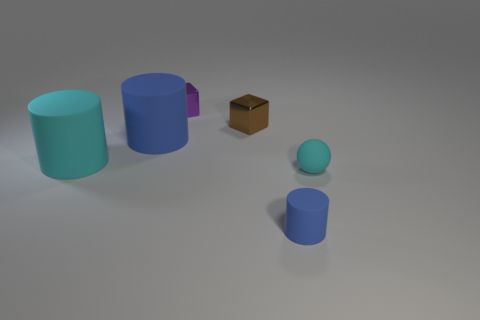How big is the cyan ball?
Your answer should be very brief. Small. Is there any other thing that is the same material as the small blue thing?
Your answer should be compact. Yes. How many tiny brown shiny blocks are behind the purple metallic thing?
Your response must be concise. 0. The other thing that is the same shape as the tiny brown object is what size?
Provide a succinct answer. Small. What is the size of the rubber object that is on the right side of the tiny purple metal thing and behind the tiny cylinder?
Offer a very short reply. Small. Do the matte sphere and the matte thing in front of the matte sphere have the same color?
Offer a very short reply. No. How many blue things are either rubber balls or metal cubes?
Give a very brief answer. 0. The small brown metal object has what shape?
Keep it short and to the point. Cube. How many other things are there of the same shape as the tiny brown object?
Offer a terse response. 1. What is the color of the big object that is left of the large blue object?
Offer a terse response. Cyan. 